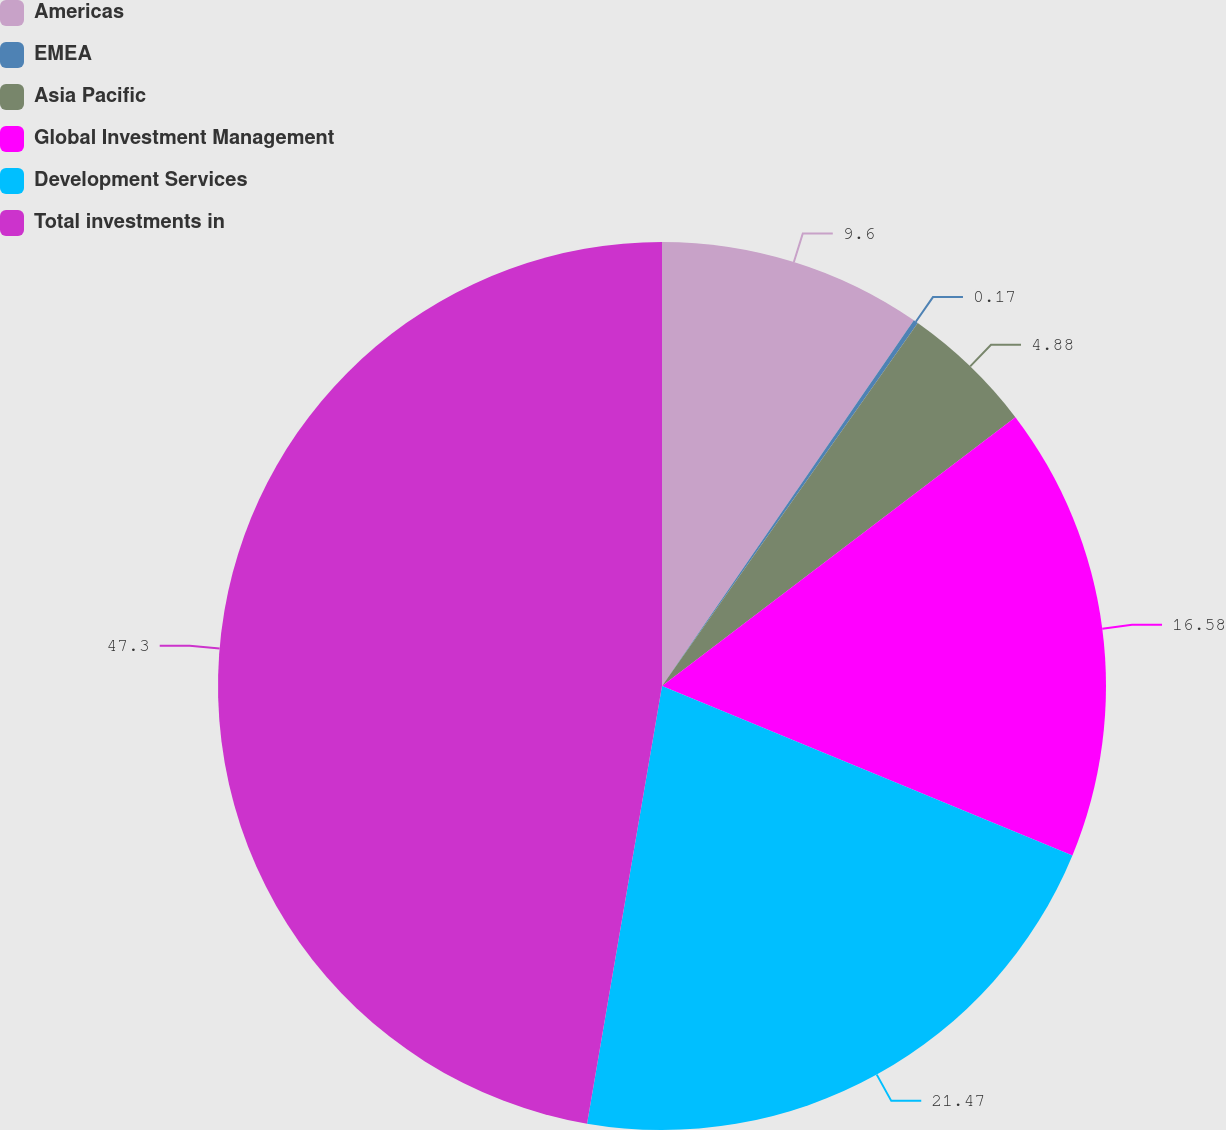Convert chart to OTSL. <chart><loc_0><loc_0><loc_500><loc_500><pie_chart><fcel>Americas<fcel>EMEA<fcel>Asia Pacific<fcel>Global Investment Management<fcel>Development Services<fcel>Total investments in<nl><fcel>9.6%<fcel>0.17%<fcel>4.88%<fcel>16.58%<fcel>21.47%<fcel>47.3%<nl></chart> 